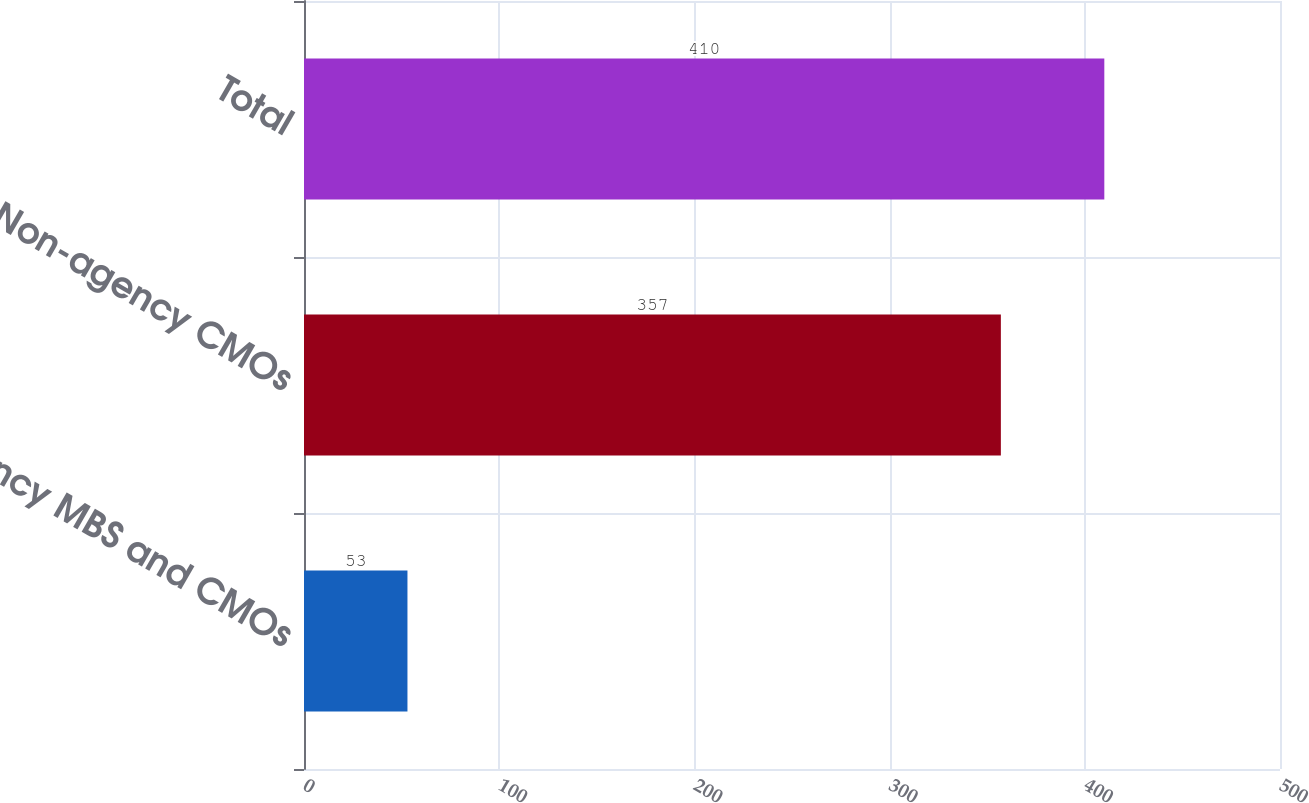Convert chart. <chart><loc_0><loc_0><loc_500><loc_500><bar_chart><fcel>Agency MBS and CMOs<fcel>Non-agency CMOs<fcel>Total<nl><fcel>53<fcel>357<fcel>410<nl></chart> 